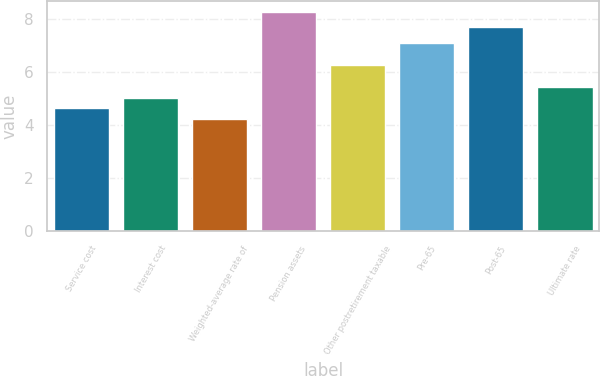Convert chart to OTSL. <chart><loc_0><loc_0><loc_500><loc_500><bar_chart><fcel>Service cost<fcel>Interest cost<fcel>Weighted-average rate of<fcel>Pension assets<fcel>Other postretirement taxable<fcel>Pre-65<fcel>Post-65<fcel>Ultimate rate<nl><fcel>4.63<fcel>5.03<fcel>4.23<fcel>8.25<fcel>6.25<fcel>7.1<fcel>7.7<fcel>5.43<nl></chart> 